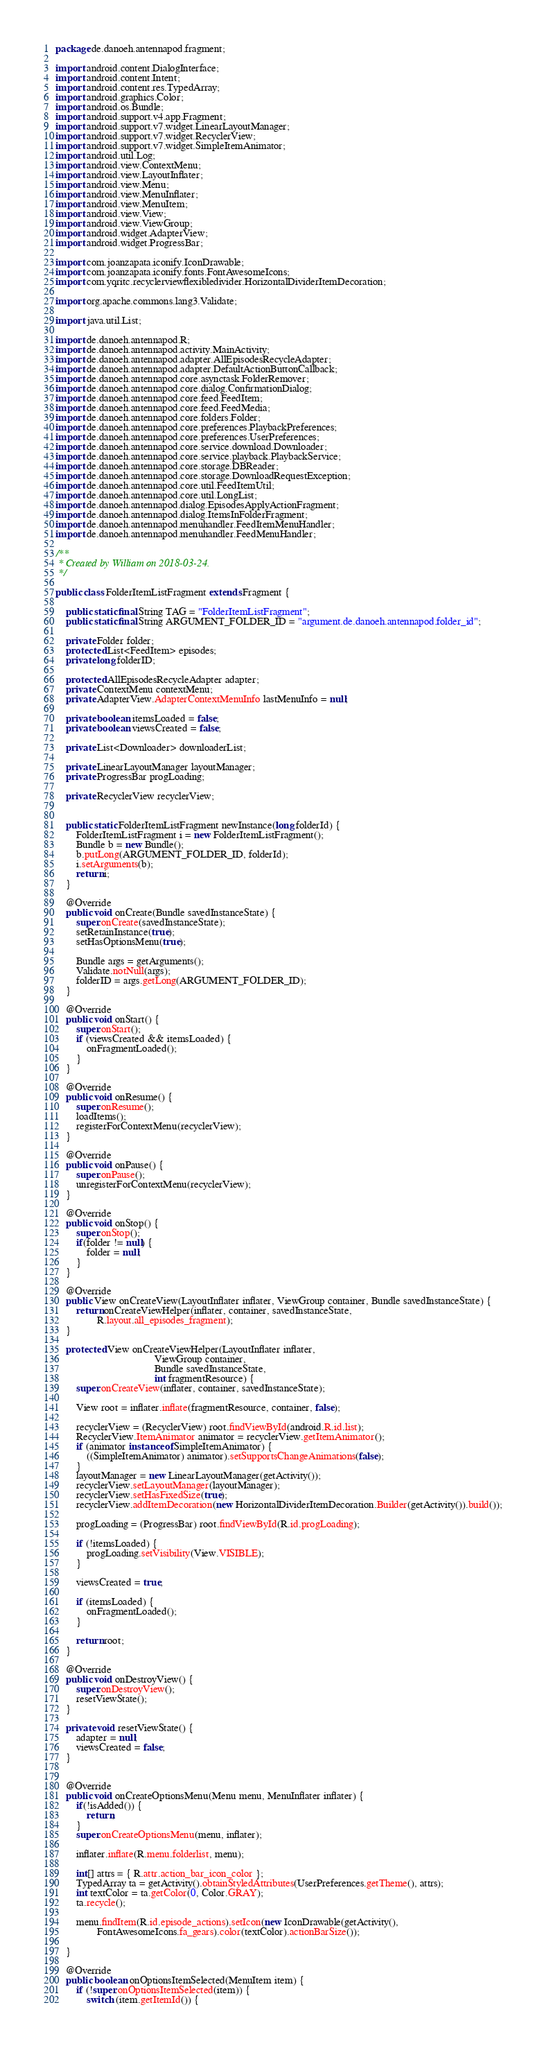Convert code to text. <code><loc_0><loc_0><loc_500><loc_500><_Java_>package de.danoeh.antennapod.fragment;

import android.content.DialogInterface;
import android.content.Intent;
import android.content.res.TypedArray;
import android.graphics.Color;
import android.os.Bundle;
import android.support.v4.app.Fragment;
import android.support.v7.widget.LinearLayoutManager;
import android.support.v7.widget.RecyclerView;
import android.support.v7.widget.SimpleItemAnimator;
import android.util.Log;
import android.view.ContextMenu;
import android.view.LayoutInflater;
import android.view.Menu;
import android.view.MenuInflater;
import android.view.MenuItem;
import android.view.View;
import android.view.ViewGroup;
import android.widget.AdapterView;
import android.widget.ProgressBar;

import com.joanzapata.iconify.IconDrawable;
import com.joanzapata.iconify.fonts.FontAwesomeIcons;
import com.yqritc.recyclerviewflexibledivider.HorizontalDividerItemDecoration;

import org.apache.commons.lang3.Validate;

import java.util.List;

import de.danoeh.antennapod.R;
import de.danoeh.antennapod.activity.MainActivity;
import de.danoeh.antennapod.adapter.AllEpisodesRecycleAdapter;
import de.danoeh.antennapod.adapter.DefaultActionButtonCallback;
import de.danoeh.antennapod.core.asynctask.FolderRemover;
import de.danoeh.antennapod.core.dialog.ConfirmationDialog;
import de.danoeh.antennapod.core.feed.FeedItem;
import de.danoeh.antennapod.core.feed.FeedMedia;
import de.danoeh.antennapod.core.folders.Folder;
import de.danoeh.antennapod.core.preferences.PlaybackPreferences;
import de.danoeh.antennapod.core.preferences.UserPreferences;
import de.danoeh.antennapod.core.service.download.Downloader;
import de.danoeh.antennapod.core.service.playback.PlaybackService;
import de.danoeh.antennapod.core.storage.DBReader;
import de.danoeh.antennapod.core.storage.DownloadRequestException;
import de.danoeh.antennapod.core.util.FeedItemUtil;
import de.danoeh.antennapod.core.util.LongList;
import de.danoeh.antennapod.dialog.EpisodesApplyActionFragment;
import de.danoeh.antennapod.dialog.ItemsInFolderFragment;
import de.danoeh.antennapod.menuhandler.FeedItemMenuHandler;
import de.danoeh.antennapod.menuhandler.FeedMenuHandler;

/**
 * Created by William on 2018-03-24.
 */

public class FolderItemListFragment extends Fragment {

    public static final String TAG = "FolderItemListFragment";
    public static final String ARGUMENT_FOLDER_ID = "argument.de.danoeh.antennapod.folder_id";

    private Folder folder;
    protected List<FeedItem> episodes;
    private long folderID;

    protected AllEpisodesRecycleAdapter adapter;
    private ContextMenu contextMenu;
    private AdapterView.AdapterContextMenuInfo lastMenuInfo = null;

    private boolean itemsLoaded = false;
    private boolean viewsCreated = false;

    private List<Downloader> downloaderList;

    private LinearLayoutManager layoutManager;
    private ProgressBar progLoading;

    private RecyclerView recyclerView;


    public static FolderItemListFragment newInstance(long folderId) {
        FolderItemListFragment i = new FolderItemListFragment();
        Bundle b = new Bundle();
        b.putLong(ARGUMENT_FOLDER_ID, folderId);
        i.setArguments(b);
        return i;
    }

    @Override
    public void onCreate(Bundle savedInstanceState) {
        super.onCreate(savedInstanceState);
        setRetainInstance(true);
        setHasOptionsMenu(true);

        Bundle args = getArguments();
        Validate.notNull(args);
        folderID = args.getLong(ARGUMENT_FOLDER_ID);
    }

    @Override
    public void onStart() {
        super.onStart();
        if (viewsCreated && itemsLoaded) {
            onFragmentLoaded();
        }
    }

    @Override
    public void onResume() {
        super.onResume();
        loadItems();
        registerForContextMenu(recyclerView);
    }

    @Override
    public void onPause() {
        super.onPause();
        unregisterForContextMenu(recyclerView);
    }

    @Override
    public void onStop() {
        super.onStop();
        if(folder != null) {
            folder = null;
        }
    }

    @Override
    public View onCreateView(LayoutInflater inflater, ViewGroup container, Bundle savedInstanceState) {
        return onCreateViewHelper(inflater, container, savedInstanceState,
                R.layout.all_episodes_fragment);
    }

    protected View onCreateViewHelper(LayoutInflater inflater,
                                      ViewGroup container,
                                      Bundle savedInstanceState,
                                      int fragmentResource) {
        super.onCreateView(inflater, container, savedInstanceState);

        View root = inflater.inflate(fragmentResource, container, false);

        recyclerView = (RecyclerView) root.findViewById(android.R.id.list);
        RecyclerView.ItemAnimator animator = recyclerView.getItemAnimator();
        if (animator instanceof SimpleItemAnimator) {
            ((SimpleItemAnimator) animator).setSupportsChangeAnimations(false);
        }
        layoutManager = new LinearLayoutManager(getActivity());
        recyclerView.setLayoutManager(layoutManager);
        recyclerView.setHasFixedSize(true);
        recyclerView.addItemDecoration(new HorizontalDividerItemDecoration.Builder(getActivity()).build());

        progLoading = (ProgressBar) root.findViewById(R.id.progLoading);

        if (!itemsLoaded) {
            progLoading.setVisibility(View.VISIBLE);
        }

        viewsCreated = true;

        if (itemsLoaded) {
            onFragmentLoaded();
        }

        return root;
    }

    @Override
    public void onDestroyView() {
        super.onDestroyView();
        resetViewState();
    }

    private void resetViewState() {
        adapter = null;
        viewsCreated = false;
    }


    @Override
    public void onCreateOptionsMenu(Menu menu, MenuInflater inflater) {
        if(!isAdded()) {
            return;
        }
        super.onCreateOptionsMenu(menu, inflater);

        inflater.inflate(R.menu.folderlist, menu);

        int[] attrs = { R.attr.action_bar_icon_color };
        TypedArray ta = getActivity().obtainStyledAttributes(UserPreferences.getTheme(), attrs);
        int textColor = ta.getColor(0, Color.GRAY);
        ta.recycle();

        menu.findItem(R.id.episode_actions).setIcon(new IconDrawable(getActivity(),
                FontAwesomeIcons.fa_gears).color(textColor).actionBarSize());

    }

    @Override
    public boolean onOptionsItemSelected(MenuItem item) {
        if (!super.onOptionsItemSelected(item)) {
            switch (item.getItemId()) {</code> 